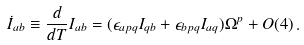Convert formula to latex. <formula><loc_0><loc_0><loc_500><loc_500>\dot { I } _ { a b } \equiv \frac { d } { d T } I _ { a b } = ( \epsilon _ { a p q } I _ { q b } + \epsilon _ { b p q } I _ { a q } ) \Omega ^ { p } + O ( 4 ) \, .</formula> 